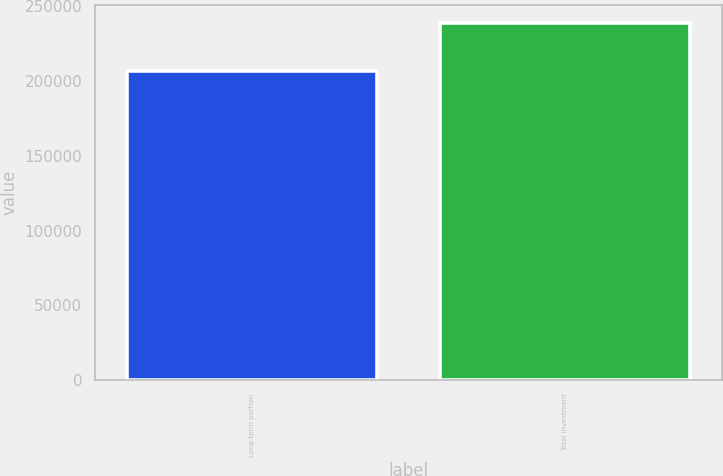Convert chart to OTSL. <chart><loc_0><loc_0><loc_500><loc_500><bar_chart><fcel>Long-term portion<fcel>Total investment<nl><fcel>206807<fcel>239042<nl></chart> 